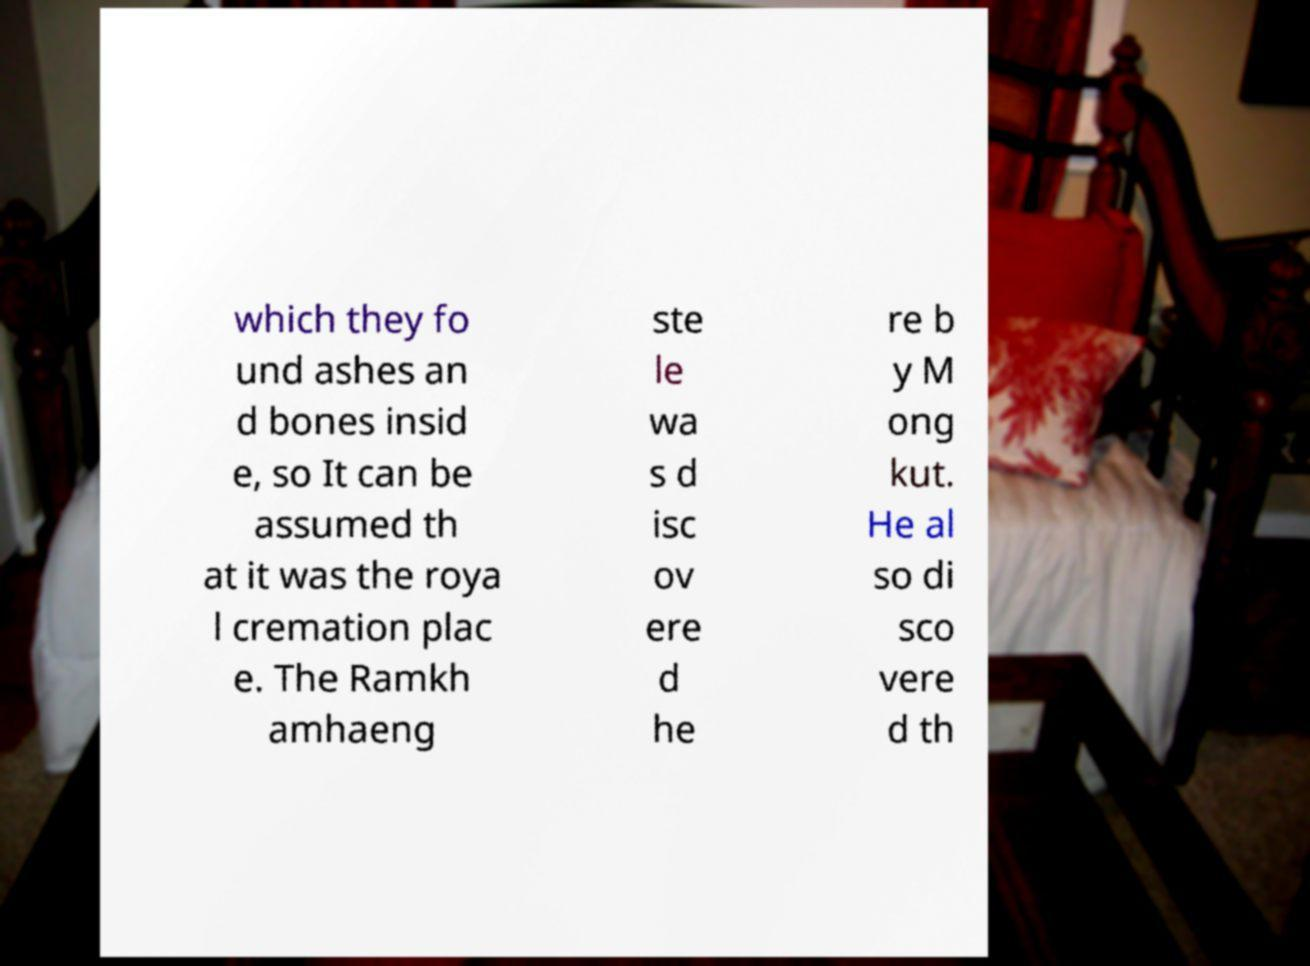I need the written content from this picture converted into text. Can you do that? which they fo und ashes an d bones insid e, so It can be assumed th at it was the roya l cremation plac e. The Ramkh amhaeng ste le wa s d isc ov ere d he re b y M ong kut. He al so di sco vere d th 